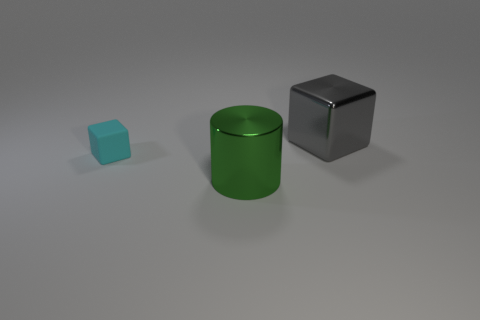Subtract all cyan cubes. How many cubes are left? 1 Add 2 gray things. How many objects exist? 5 Subtract all blocks. How many objects are left? 1 Subtract 1 cylinders. How many cylinders are left? 0 Subtract all cyan blocks. Subtract all green balls. How many blocks are left? 1 Subtract all green balls. How many red cubes are left? 0 Subtract all small cyan shiny blocks. Subtract all large green cylinders. How many objects are left? 2 Add 2 cyan rubber cubes. How many cyan rubber cubes are left? 3 Add 2 cyan matte things. How many cyan matte things exist? 3 Subtract 0 gray cylinders. How many objects are left? 3 